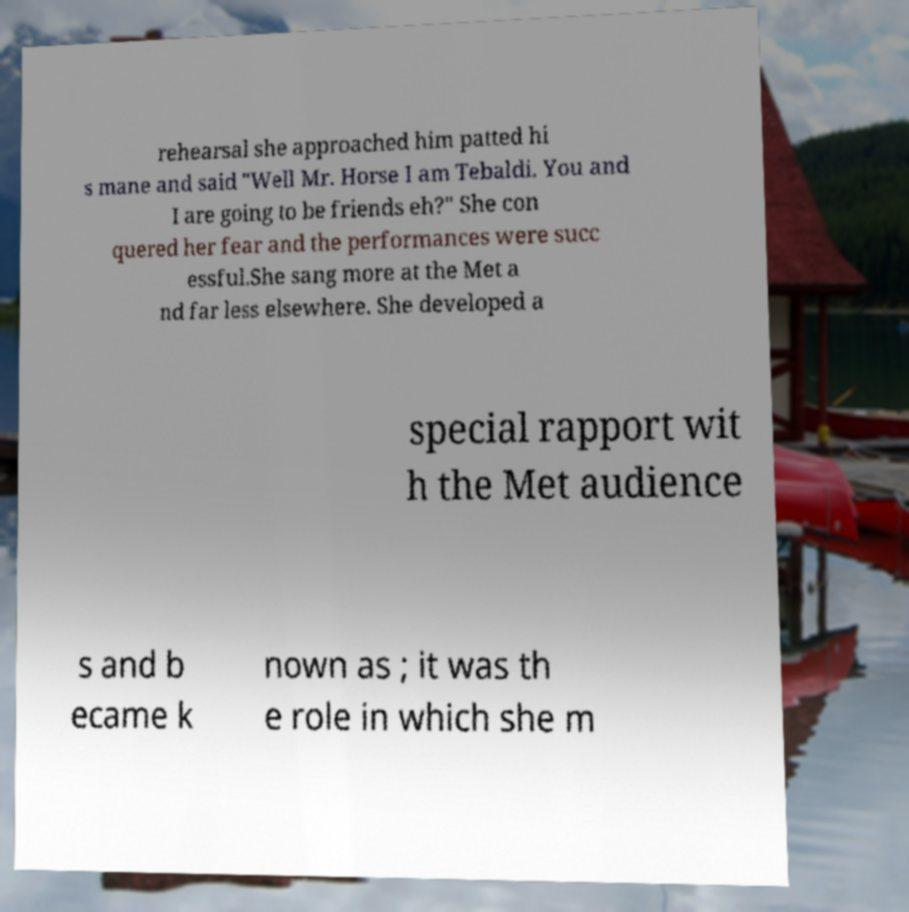Please read and relay the text visible in this image. What does it say? rehearsal she approached him patted hi s mane and said "Well Mr. Horse I am Tebaldi. You and I are going to be friends eh?" She con quered her fear and the performances were succ essful.She sang more at the Met a nd far less elsewhere. She developed a special rapport wit h the Met audience s and b ecame k nown as ; it was th e role in which she m 